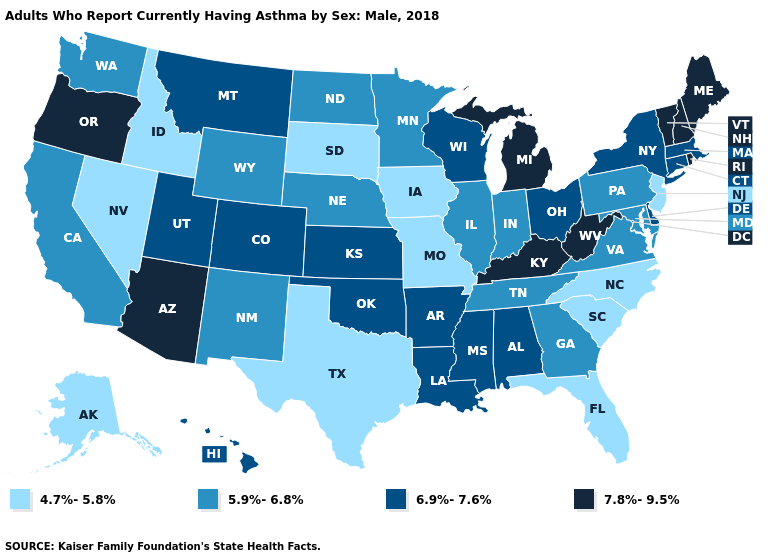Among the states that border Nebraska , which have the highest value?
Answer briefly. Colorado, Kansas. What is the lowest value in the USA?
Concise answer only. 4.7%-5.8%. Does Vermont have a higher value than Arizona?
Keep it brief. No. Name the states that have a value in the range 4.7%-5.8%?
Short answer required. Alaska, Florida, Idaho, Iowa, Missouri, Nevada, New Jersey, North Carolina, South Carolina, South Dakota, Texas. Name the states that have a value in the range 7.8%-9.5%?
Give a very brief answer. Arizona, Kentucky, Maine, Michigan, New Hampshire, Oregon, Rhode Island, Vermont, West Virginia. Name the states that have a value in the range 7.8%-9.5%?
Write a very short answer. Arizona, Kentucky, Maine, Michigan, New Hampshire, Oregon, Rhode Island, Vermont, West Virginia. Does the map have missing data?
Write a very short answer. No. What is the lowest value in the South?
Give a very brief answer. 4.7%-5.8%. What is the value of Rhode Island?
Concise answer only. 7.8%-9.5%. What is the value of Virginia?
Concise answer only. 5.9%-6.8%. What is the value of Arizona?
Short answer required. 7.8%-9.5%. Does Michigan have the same value as Mississippi?
Be succinct. No. What is the value of New York?
Write a very short answer. 6.9%-7.6%. Name the states that have a value in the range 6.9%-7.6%?
Keep it brief. Alabama, Arkansas, Colorado, Connecticut, Delaware, Hawaii, Kansas, Louisiana, Massachusetts, Mississippi, Montana, New York, Ohio, Oklahoma, Utah, Wisconsin. Does North Carolina have the lowest value in the USA?
Answer briefly. Yes. 